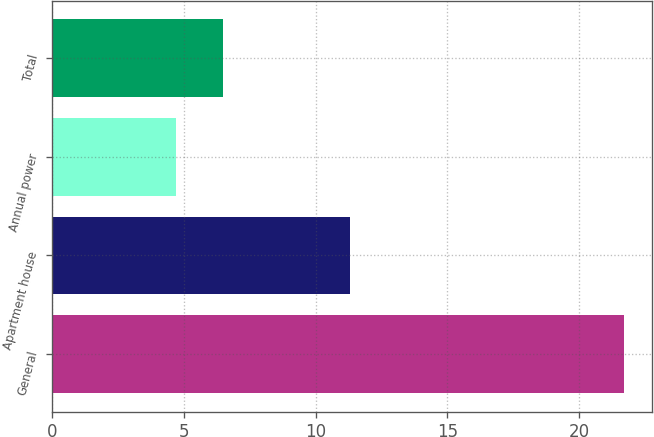Convert chart. <chart><loc_0><loc_0><loc_500><loc_500><bar_chart><fcel>General<fcel>Apartment house<fcel>Annual power<fcel>Total<nl><fcel>21.7<fcel>11.3<fcel>4.7<fcel>6.5<nl></chart> 